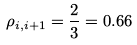<formula> <loc_0><loc_0><loc_500><loc_500>\rho _ { i , i + 1 } = \frac { 2 } { 3 } = 0 . 6 6</formula> 